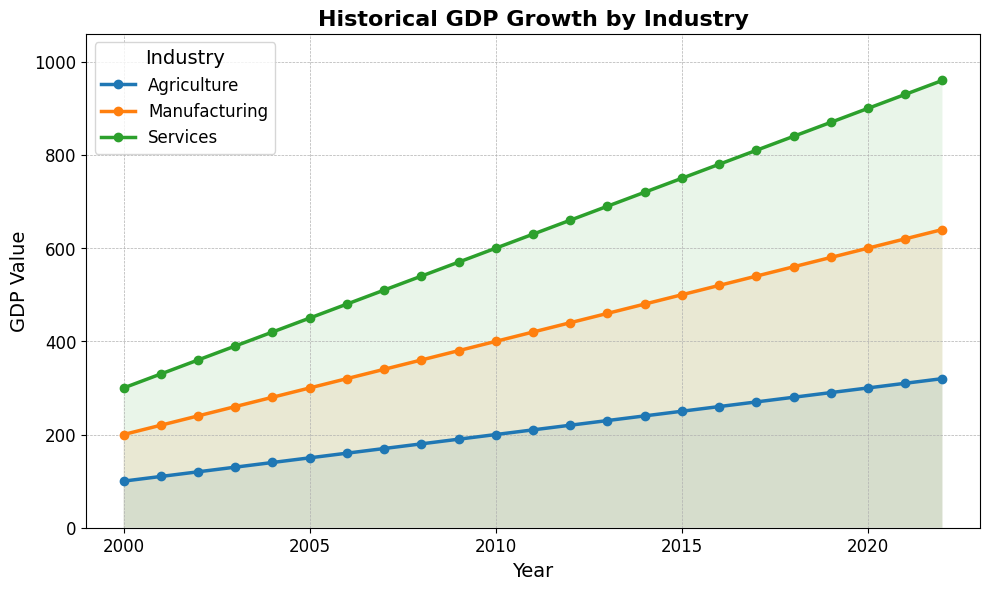Which industry showed the highest GDP value in 2022? Look at the 2022 end of the chart and compare the heights of the lines for each industry. The Services industry line is the highest.
Answer: Services In which year did the Agriculture industry have a GDP value of 250? Locate the Agriculture line on the chart and find where it intersects with the y-axis at 250. Note the corresponding year on the x-axis.
Answer: 2015 What was the GDP difference between Manufacturing and Services in 2010? For 2010, find the points for Manufacturing and Services on the chart. The Manufacturing value is 400, and the Services value is 600. Subtract the Manufacturing value from the Services value.
Answer: 200 Which industry had the steadiest growth from 2000 to 2022? Compare the smoothness and consistency of the growth lines for each industry over time. The Services line appears the most consistently upward without dips or spikes.
Answer: Services What is the total GDP value for all industries combined in the year 2005? For 2005, find the values for Agriculture, Manufacturing, and Services. Sum these values: 150 (Agriculture) + 300 (Manufacturing) + 450 (Services) = 900.
Answer: 900 Between which two years did the Manufacturing industry show the greatest increase in GDP value? Observe the Manufacturing line and identify the steepest upward segment between two consecutive years. The steepest increase appears between 2011 and 2012.
Answer: 2011–2012 How did the GDP value of Agriculture in 2020 compare to its value in 2010? Locate the Agriculture line in 2010 and 2020. The values are 200 in 2010 and 300 in 2020. The value increased by 100.
Answer: Increased by 100 By how much did the GDP of the Services industry increase from 2000 to 2020? Compare the start and end points of the Services line in 2000 and 2020. The values are 300 (2000) and 900 (2020). Subtract the 2000 value from the 2020 value: 900 - 300 = 600.
Answer: 600 Which industry had its GDP first reach above 500? In which year did it happen? Follow each industry's line and find the first time it crosses the 500 mark. This happens first for the Services industry in 2004.
Answer: Services, 2004 In 2015, how did the GDP value of Manufacturing compare to the Services industry? Locate the values for Manufacturing and Services in 2015 on the chart. Manufacturing value is 500 and Services value is 750. Manufacturing is less than Services by 250.
Answer: Manufacturing is less by 250 